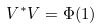Convert formula to latex. <formula><loc_0><loc_0><loc_500><loc_500>V ^ { * } V = \Phi ( 1 )</formula> 